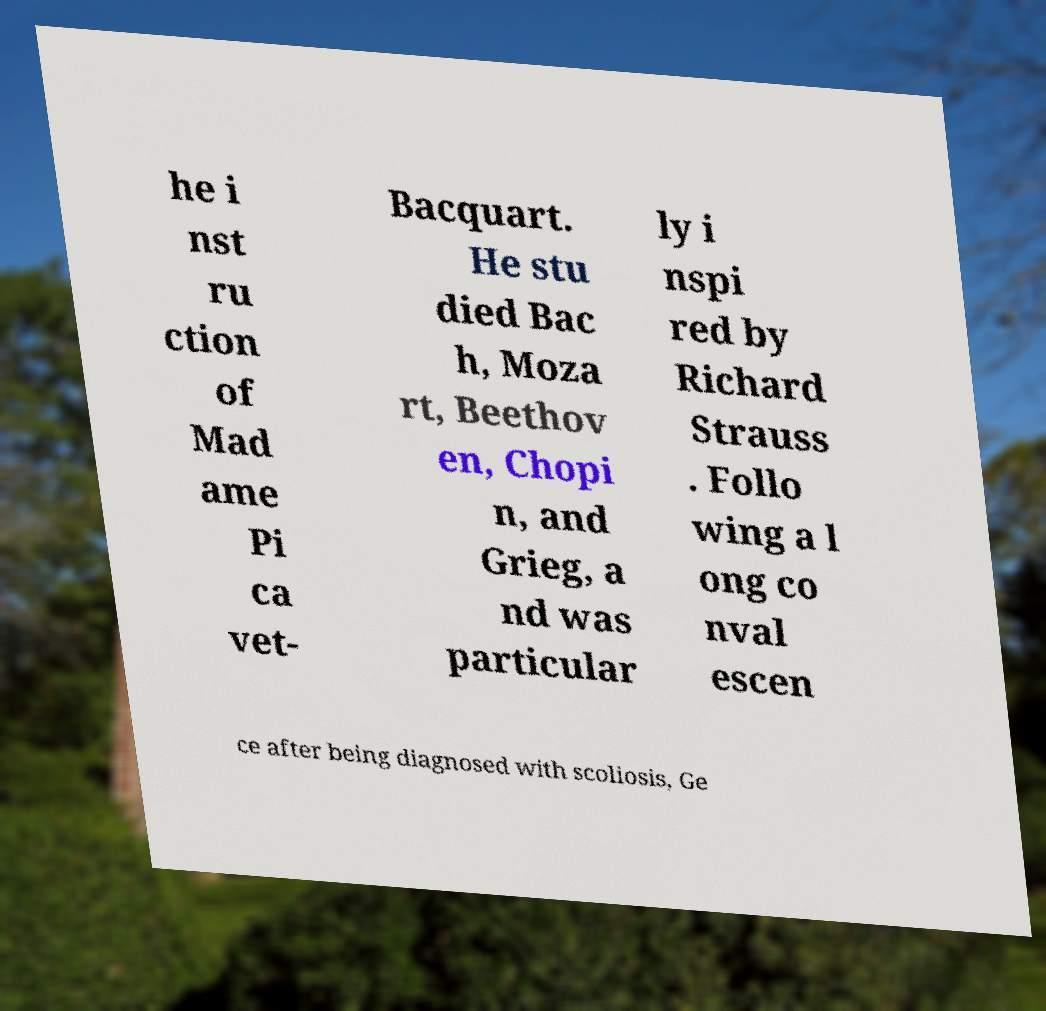For documentation purposes, I need the text within this image transcribed. Could you provide that? he i nst ru ction of Mad ame Pi ca vet- Bacquart. He stu died Bac h, Moza rt, Beethov en, Chopi n, and Grieg, a nd was particular ly i nspi red by Richard Strauss . Follo wing a l ong co nval escen ce after being diagnosed with scoliosis, Ge 